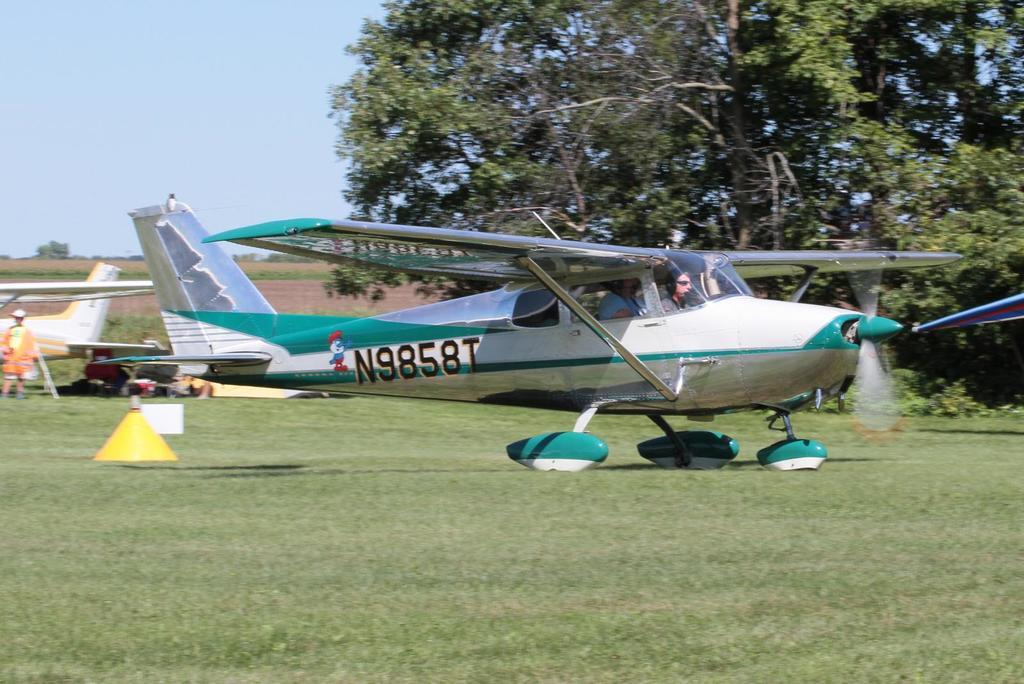<image>
Create a compact narrative representing the image presented. A N9858T air plane standing on a grassy filed with the pilot sitting at the controls. 